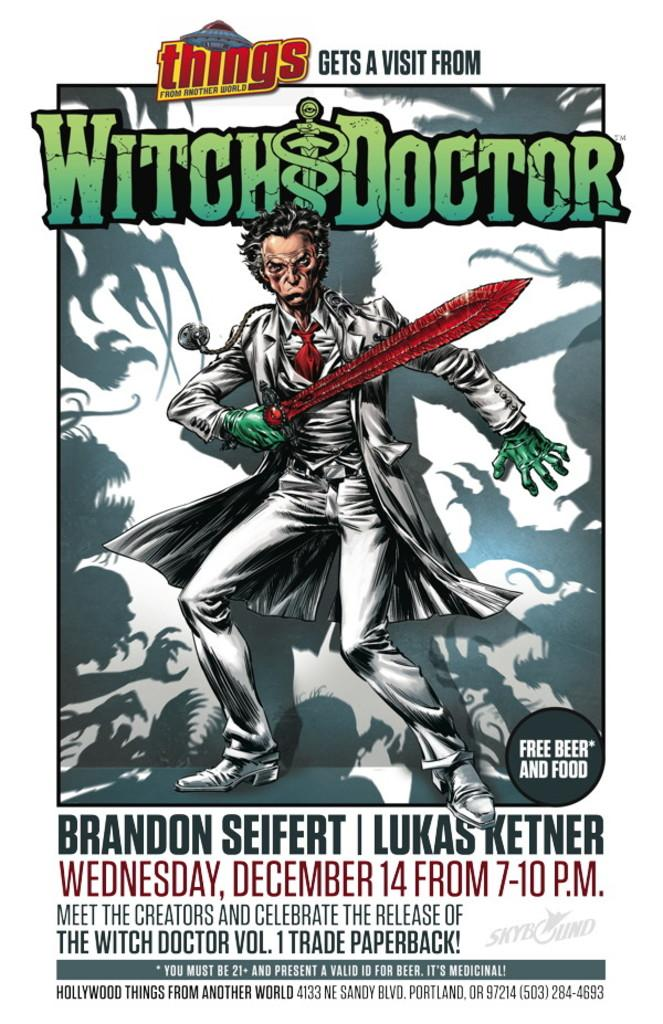<image>
Describe the image concisely. An ad for an event to meet the creators of The Witch Doctor Vol.1. 